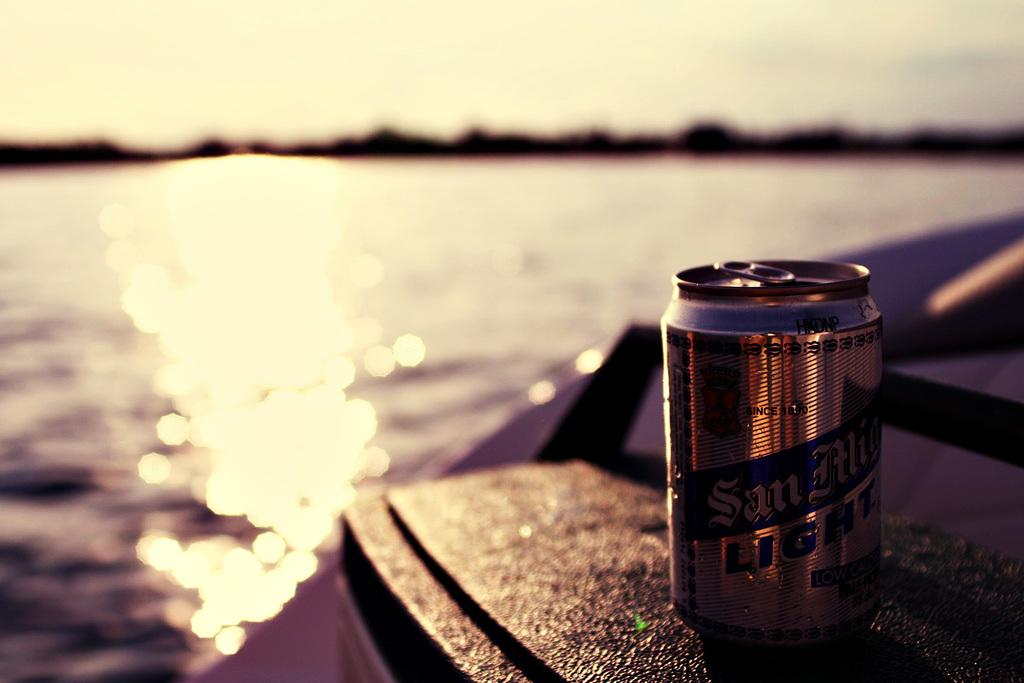<image>
Provide a brief description of the given image. A gold and blue can of Light BEER sitting on a table by a large body of water. 